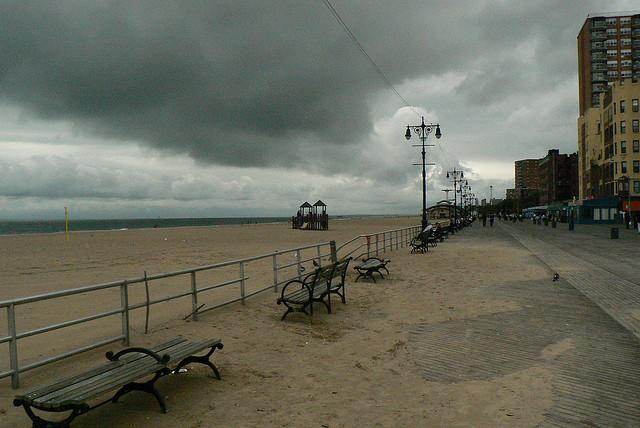Why is the beach empty?

Choices:
A) pollution
B) storm coming
C) work day
D) lockdown storm coming 